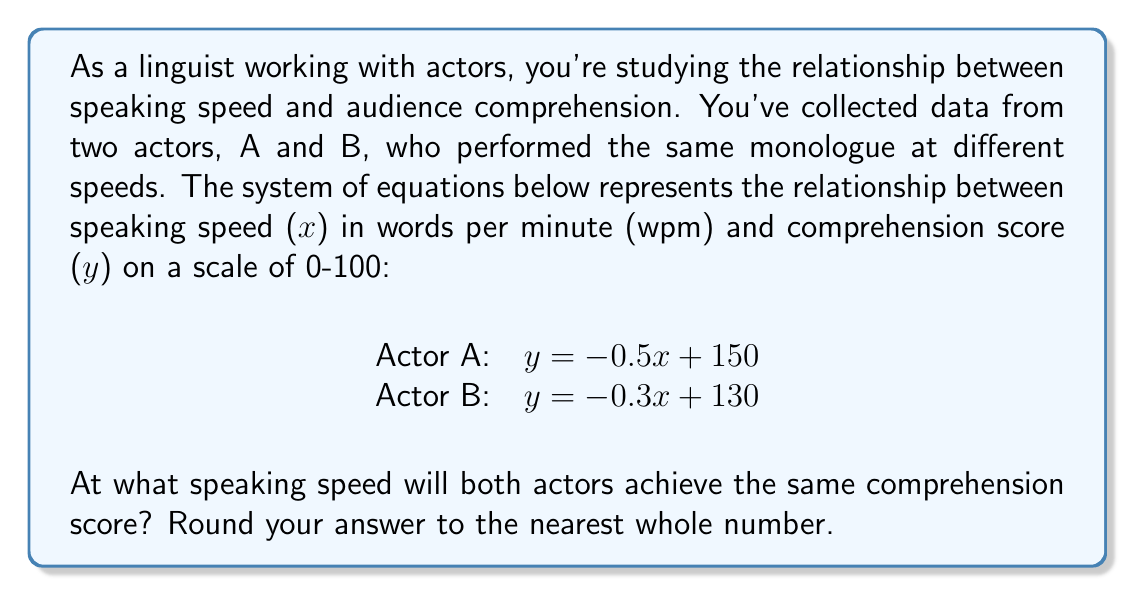Show me your answer to this math problem. To solve this problem, we need to find the point of intersection between the two linear equations. This point represents the speaking speed at which both actors will achieve the same comprehension score.

1. Set the two equations equal to each other:
   $-0.5x + 150 = -0.3x + 130$

2. Solve for x:
   $-0.5x + 150 = -0.3x + 130$
   $-0.5x + 20 = -0.3x$
   $-0.2x = -20$
   $x = 100$

3. Verify the solution by plugging x = 100 into both equations:
   Actor A: $y = -0.5(100) + 150 = -50 + 150 = 100$
   Actor B: $y = -0.3(100) + 130 = -30 + 130 = 100$

Both equations yield the same y-value (comprehension score) when x = 100, confirming our solution.

4. Round to the nearest whole number:
   100 is already a whole number, so no rounding is necessary.
Answer: 100 wpm 